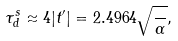Convert formula to latex. <formula><loc_0><loc_0><loc_500><loc_500>\tau ^ { s } _ { d } \approx 4 | t ^ { \prime } | = 2 . 4 9 6 4 \sqrt { \frac { } { \alpha } } ,</formula> 